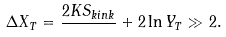<formula> <loc_0><loc_0><loc_500><loc_500>\Delta X _ { T } = \frac { 2 K S _ { k i n k } } { } + 2 \ln { Y _ { T } } \gg 2 .</formula> 